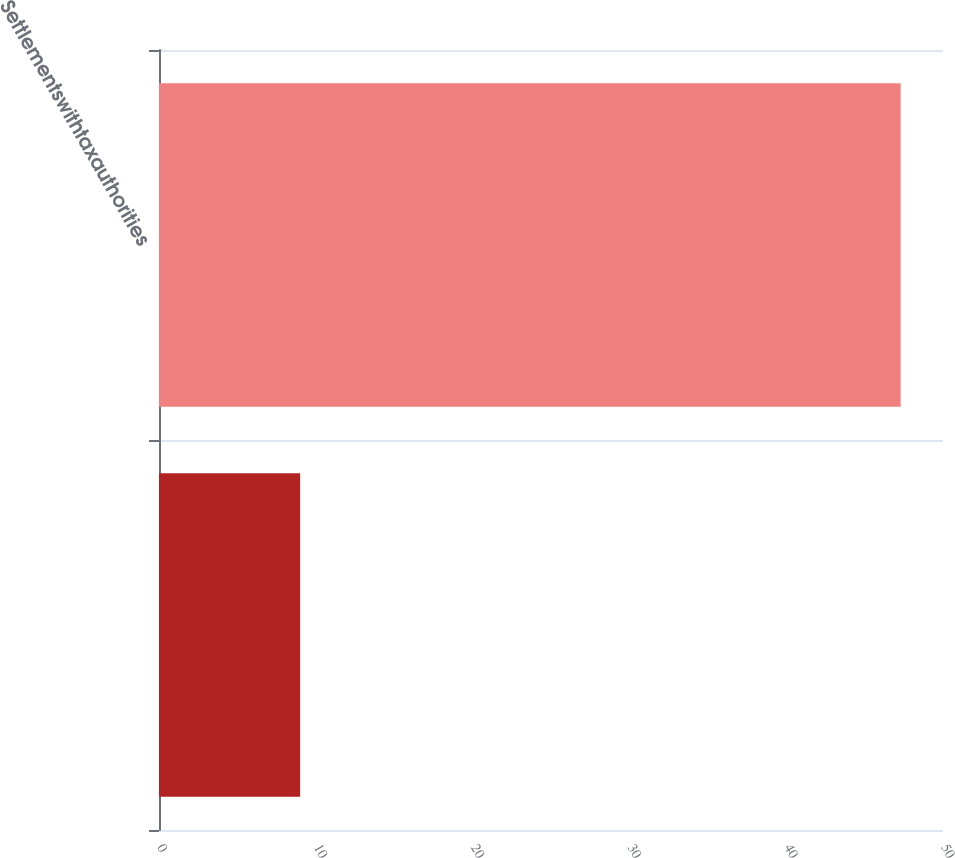Convert chart to OTSL. <chart><loc_0><loc_0><loc_500><loc_500><bar_chart><ecel><fcel>Settlementswithtaxauthorities<nl><fcel>9<fcel>47.3<nl></chart> 